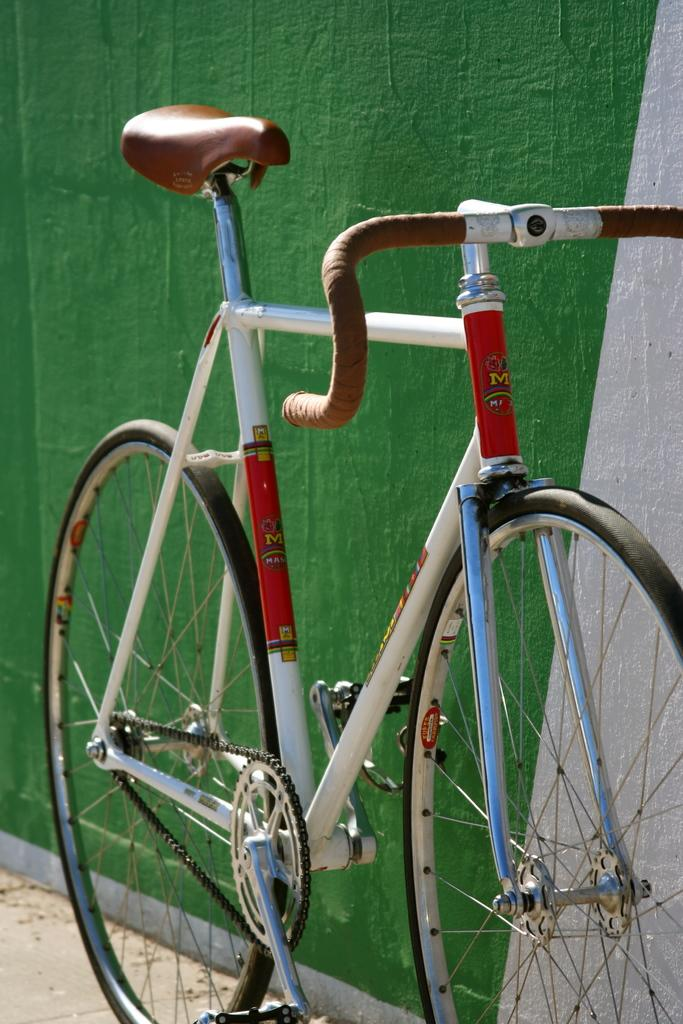What is the main object in the image? There is a bicycle in the image. What can be seen in the background of the image? There is a wall in the background of the image. What is the surface on which the bicycle appears to be placed? There is a floor at the bottom of the image. Where is the dock located in the image? There is no dock present in the image. What type of wine is being served in the image? There is no wine present in the image. 